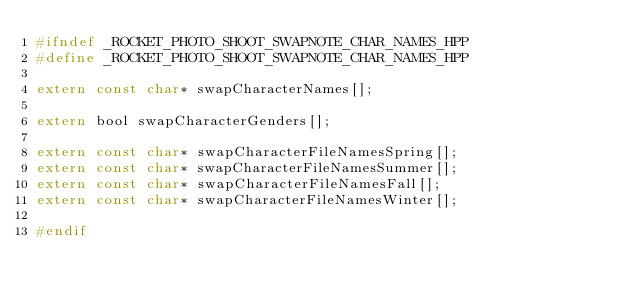Convert code to text. <code><loc_0><loc_0><loc_500><loc_500><_C_>#ifndef _ROCKET_PHOTO_SHOOT_SWAPNOTE_CHAR_NAMES_HPP
#define _ROCKET_PHOTO_SHOOT_SWAPNOTE_CHAR_NAMES_HPP

extern const char* swapCharacterNames[];

extern bool swapCharacterGenders[];

extern const char* swapCharacterFileNamesSpring[];
extern const char* swapCharacterFileNamesSummer[];
extern const char* swapCharacterFileNamesFall[];
extern const char* swapCharacterFileNamesWinter[];

#endif</code> 